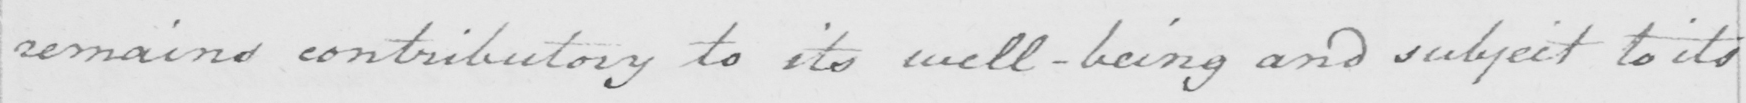Please transcribe the handwritten text in this image. remains contributory to its well-being and subject to its 